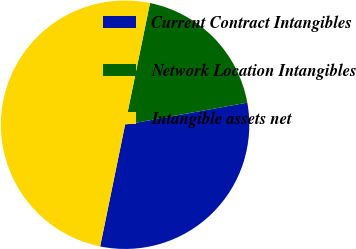<chart> <loc_0><loc_0><loc_500><loc_500><pie_chart><fcel>Current Contract Intangibles<fcel>Network Location Intangibles<fcel>Intangible assets net<nl><fcel>31.06%<fcel>18.94%<fcel>50.0%<nl></chart> 